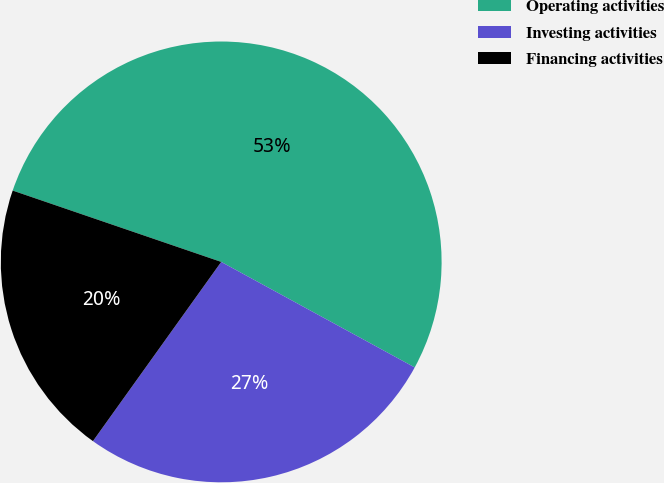Convert chart. <chart><loc_0><loc_0><loc_500><loc_500><pie_chart><fcel>Operating activities<fcel>Investing activities<fcel>Financing activities<nl><fcel>52.7%<fcel>26.94%<fcel>20.36%<nl></chart> 